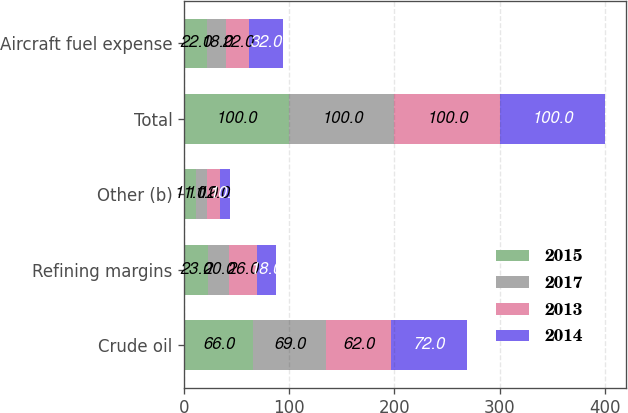Convert chart to OTSL. <chart><loc_0><loc_0><loc_500><loc_500><stacked_bar_chart><ecel><fcel>Crude oil<fcel>Refining margins<fcel>Other (b)<fcel>Total<fcel>Aircraft fuel expense<nl><fcel>2015<fcel>66<fcel>23<fcel>11<fcel>100<fcel>22<nl><fcel>2017<fcel>69<fcel>20<fcel>11<fcel>100<fcel>18<nl><fcel>2013<fcel>62<fcel>26<fcel>12<fcel>100<fcel>22<nl><fcel>2014<fcel>72<fcel>18<fcel>10<fcel>100<fcel>32<nl></chart> 